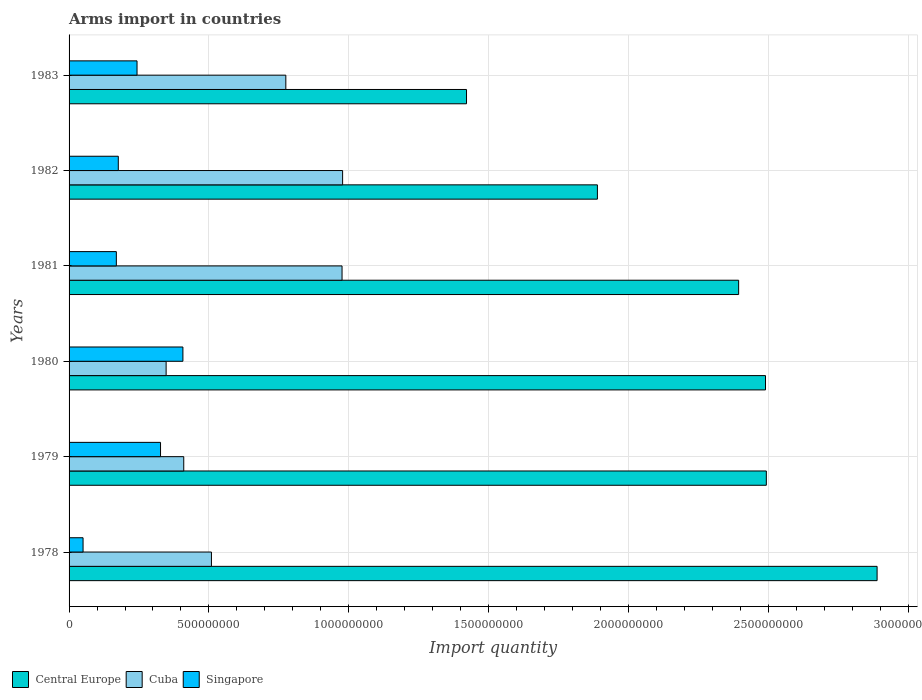How many different coloured bars are there?
Give a very brief answer. 3. Are the number of bars per tick equal to the number of legend labels?
Your answer should be very brief. Yes. Are the number of bars on each tick of the Y-axis equal?
Offer a very short reply. Yes. How many bars are there on the 6th tick from the bottom?
Give a very brief answer. 3. What is the total arms import in Singapore in 1980?
Your answer should be compact. 4.07e+08. Across all years, what is the maximum total arms import in Singapore?
Provide a succinct answer. 4.07e+08. Across all years, what is the minimum total arms import in Cuba?
Ensure brevity in your answer.  3.47e+08. In which year was the total arms import in Central Europe maximum?
Your response must be concise. 1978. In which year was the total arms import in Singapore minimum?
Keep it short and to the point. 1978. What is the total total arms import in Central Europe in the graph?
Your answer should be compact. 1.36e+1. What is the difference between the total arms import in Central Europe in 1981 and that in 1982?
Your response must be concise. 5.05e+08. What is the difference between the total arms import in Cuba in 1978 and the total arms import in Central Europe in 1983?
Provide a short and direct response. -9.12e+08. What is the average total arms import in Singapore per year?
Your answer should be very brief. 2.29e+08. In the year 1978, what is the difference between the total arms import in Singapore and total arms import in Cuba?
Provide a succinct answer. -4.59e+08. What is the ratio of the total arms import in Cuba in 1979 to that in 1982?
Keep it short and to the point. 0.42. Is the difference between the total arms import in Singapore in 1981 and 1983 greater than the difference between the total arms import in Cuba in 1981 and 1983?
Offer a terse response. No. What is the difference between the highest and the second highest total arms import in Central Europe?
Ensure brevity in your answer.  3.96e+08. What is the difference between the highest and the lowest total arms import in Central Europe?
Offer a very short reply. 1.47e+09. What does the 2nd bar from the top in 1979 represents?
Provide a succinct answer. Cuba. What does the 2nd bar from the bottom in 1978 represents?
Keep it short and to the point. Cuba. Is it the case that in every year, the sum of the total arms import in Singapore and total arms import in Cuba is greater than the total arms import in Central Europe?
Ensure brevity in your answer.  No. How many bars are there?
Your answer should be very brief. 18. Are the values on the major ticks of X-axis written in scientific E-notation?
Provide a succinct answer. No. Where does the legend appear in the graph?
Provide a succinct answer. Bottom left. How many legend labels are there?
Ensure brevity in your answer.  3. What is the title of the graph?
Keep it short and to the point. Arms import in countries. Does "Central African Republic" appear as one of the legend labels in the graph?
Provide a short and direct response. No. What is the label or title of the X-axis?
Your answer should be compact. Import quantity. What is the Import quantity of Central Europe in 1978?
Your answer should be compact. 2.89e+09. What is the Import quantity in Cuba in 1978?
Provide a succinct answer. 5.09e+08. What is the Import quantity of Central Europe in 1979?
Provide a short and direct response. 2.49e+09. What is the Import quantity in Cuba in 1979?
Your response must be concise. 4.10e+08. What is the Import quantity of Singapore in 1979?
Give a very brief answer. 3.27e+08. What is the Import quantity in Central Europe in 1980?
Ensure brevity in your answer.  2.49e+09. What is the Import quantity of Cuba in 1980?
Ensure brevity in your answer.  3.47e+08. What is the Import quantity of Singapore in 1980?
Your answer should be compact. 4.07e+08. What is the Import quantity in Central Europe in 1981?
Make the answer very short. 2.39e+09. What is the Import quantity of Cuba in 1981?
Your response must be concise. 9.76e+08. What is the Import quantity in Singapore in 1981?
Your response must be concise. 1.69e+08. What is the Import quantity in Central Europe in 1982?
Make the answer very short. 1.89e+09. What is the Import quantity of Cuba in 1982?
Your response must be concise. 9.78e+08. What is the Import quantity in Singapore in 1982?
Your answer should be compact. 1.76e+08. What is the Import quantity in Central Europe in 1983?
Offer a terse response. 1.42e+09. What is the Import quantity in Cuba in 1983?
Your response must be concise. 7.75e+08. What is the Import quantity of Singapore in 1983?
Your answer should be compact. 2.43e+08. Across all years, what is the maximum Import quantity of Central Europe?
Give a very brief answer. 2.89e+09. Across all years, what is the maximum Import quantity of Cuba?
Give a very brief answer. 9.78e+08. Across all years, what is the maximum Import quantity in Singapore?
Make the answer very short. 4.07e+08. Across all years, what is the minimum Import quantity of Central Europe?
Your answer should be very brief. 1.42e+09. Across all years, what is the minimum Import quantity of Cuba?
Give a very brief answer. 3.47e+08. Across all years, what is the minimum Import quantity in Singapore?
Offer a very short reply. 5.00e+07. What is the total Import quantity in Central Europe in the graph?
Offer a terse response. 1.36e+1. What is the total Import quantity of Cuba in the graph?
Provide a short and direct response. 4.00e+09. What is the total Import quantity of Singapore in the graph?
Offer a very short reply. 1.37e+09. What is the difference between the Import quantity of Central Europe in 1978 and that in 1979?
Provide a succinct answer. 3.96e+08. What is the difference between the Import quantity in Cuba in 1978 and that in 1979?
Ensure brevity in your answer.  9.90e+07. What is the difference between the Import quantity of Singapore in 1978 and that in 1979?
Your answer should be compact. -2.77e+08. What is the difference between the Import quantity in Central Europe in 1978 and that in 1980?
Offer a terse response. 3.99e+08. What is the difference between the Import quantity in Cuba in 1978 and that in 1980?
Offer a terse response. 1.62e+08. What is the difference between the Import quantity in Singapore in 1978 and that in 1980?
Offer a very short reply. -3.57e+08. What is the difference between the Import quantity in Central Europe in 1978 and that in 1981?
Your answer should be very brief. 4.95e+08. What is the difference between the Import quantity of Cuba in 1978 and that in 1981?
Provide a short and direct response. -4.67e+08. What is the difference between the Import quantity of Singapore in 1978 and that in 1981?
Your answer should be compact. -1.19e+08. What is the difference between the Import quantity in Cuba in 1978 and that in 1982?
Make the answer very short. -4.69e+08. What is the difference between the Import quantity of Singapore in 1978 and that in 1982?
Make the answer very short. -1.26e+08. What is the difference between the Import quantity of Central Europe in 1978 and that in 1983?
Your answer should be compact. 1.47e+09. What is the difference between the Import quantity of Cuba in 1978 and that in 1983?
Make the answer very short. -2.66e+08. What is the difference between the Import quantity of Singapore in 1978 and that in 1983?
Your answer should be compact. -1.93e+08. What is the difference between the Import quantity in Cuba in 1979 and that in 1980?
Provide a short and direct response. 6.30e+07. What is the difference between the Import quantity in Singapore in 1979 and that in 1980?
Provide a short and direct response. -8.00e+07. What is the difference between the Import quantity in Central Europe in 1979 and that in 1981?
Offer a terse response. 9.90e+07. What is the difference between the Import quantity of Cuba in 1979 and that in 1981?
Keep it short and to the point. -5.66e+08. What is the difference between the Import quantity of Singapore in 1979 and that in 1981?
Provide a short and direct response. 1.58e+08. What is the difference between the Import quantity of Central Europe in 1979 and that in 1982?
Your response must be concise. 6.04e+08. What is the difference between the Import quantity in Cuba in 1979 and that in 1982?
Your response must be concise. -5.68e+08. What is the difference between the Import quantity of Singapore in 1979 and that in 1982?
Offer a terse response. 1.51e+08. What is the difference between the Import quantity of Central Europe in 1979 and that in 1983?
Make the answer very short. 1.07e+09. What is the difference between the Import quantity in Cuba in 1979 and that in 1983?
Offer a terse response. -3.65e+08. What is the difference between the Import quantity of Singapore in 1979 and that in 1983?
Offer a terse response. 8.40e+07. What is the difference between the Import quantity in Central Europe in 1980 and that in 1981?
Provide a succinct answer. 9.60e+07. What is the difference between the Import quantity of Cuba in 1980 and that in 1981?
Your answer should be compact. -6.29e+08. What is the difference between the Import quantity in Singapore in 1980 and that in 1981?
Give a very brief answer. 2.38e+08. What is the difference between the Import quantity of Central Europe in 1980 and that in 1982?
Provide a succinct answer. 6.01e+08. What is the difference between the Import quantity in Cuba in 1980 and that in 1982?
Provide a succinct answer. -6.31e+08. What is the difference between the Import quantity in Singapore in 1980 and that in 1982?
Your response must be concise. 2.31e+08. What is the difference between the Import quantity in Central Europe in 1980 and that in 1983?
Give a very brief answer. 1.07e+09. What is the difference between the Import quantity of Cuba in 1980 and that in 1983?
Keep it short and to the point. -4.28e+08. What is the difference between the Import quantity in Singapore in 1980 and that in 1983?
Ensure brevity in your answer.  1.64e+08. What is the difference between the Import quantity of Central Europe in 1981 and that in 1982?
Offer a terse response. 5.05e+08. What is the difference between the Import quantity of Singapore in 1981 and that in 1982?
Provide a short and direct response. -7.00e+06. What is the difference between the Import quantity of Central Europe in 1981 and that in 1983?
Give a very brief answer. 9.73e+08. What is the difference between the Import quantity in Cuba in 1981 and that in 1983?
Keep it short and to the point. 2.01e+08. What is the difference between the Import quantity in Singapore in 1981 and that in 1983?
Give a very brief answer. -7.40e+07. What is the difference between the Import quantity in Central Europe in 1982 and that in 1983?
Your answer should be very brief. 4.68e+08. What is the difference between the Import quantity in Cuba in 1982 and that in 1983?
Provide a succinct answer. 2.03e+08. What is the difference between the Import quantity in Singapore in 1982 and that in 1983?
Your answer should be compact. -6.70e+07. What is the difference between the Import quantity of Central Europe in 1978 and the Import quantity of Cuba in 1979?
Your response must be concise. 2.48e+09. What is the difference between the Import quantity of Central Europe in 1978 and the Import quantity of Singapore in 1979?
Provide a short and direct response. 2.56e+09. What is the difference between the Import quantity in Cuba in 1978 and the Import quantity in Singapore in 1979?
Offer a terse response. 1.82e+08. What is the difference between the Import quantity in Central Europe in 1978 and the Import quantity in Cuba in 1980?
Keep it short and to the point. 2.54e+09. What is the difference between the Import quantity in Central Europe in 1978 and the Import quantity in Singapore in 1980?
Ensure brevity in your answer.  2.48e+09. What is the difference between the Import quantity in Cuba in 1978 and the Import quantity in Singapore in 1980?
Offer a terse response. 1.02e+08. What is the difference between the Import quantity of Central Europe in 1978 and the Import quantity of Cuba in 1981?
Give a very brief answer. 1.91e+09. What is the difference between the Import quantity of Central Europe in 1978 and the Import quantity of Singapore in 1981?
Provide a short and direct response. 2.72e+09. What is the difference between the Import quantity of Cuba in 1978 and the Import quantity of Singapore in 1981?
Offer a very short reply. 3.40e+08. What is the difference between the Import quantity of Central Europe in 1978 and the Import quantity of Cuba in 1982?
Provide a succinct answer. 1.91e+09. What is the difference between the Import quantity of Central Europe in 1978 and the Import quantity of Singapore in 1982?
Ensure brevity in your answer.  2.71e+09. What is the difference between the Import quantity of Cuba in 1978 and the Import quantity of Singapore in 1982?
Ensure brevity in your answer.  3.33e+08. What is the difference between the Import quantity in Central Europe in 1978 and the Import quantity in Cuba in 1983?
Your response must be concise. 2.11e+09. What is the difference between the Import quantity in Central Europe in 1978 and the Import quantity in Singapore in 1983?
Your response must be concise. 2.65e+09. What is the difference between the Import quantity of Cuba in 1978 and the Import quantity of Singapore in 1983?
Make the answer very short. 2.66e+08. What is the difference between the Import quantity of Central Europe in 1979 and the Import quantity of Cuba in 1980?
Give a very brief answer. 2.15e+09. What is the difference between the Import quantity in Central Europe in 1979 and the Import quantity in Singapore in 1980?
Offer a terse response. 2.09e+09. What is the difference between the Import quantity in Central Europe in 1979 and the Import quantity in Cuba in 1981?
Keep it short and to the point. 1.52e+09. What is the difference between the Import quantity in Central Europe in 1979 and the Import quantity in Singapore in 1981?
Offer a very short reply. 2.32e+09. What is the difference between the Import quantity in Cuba in 1979 and the Import quantity in Singapore in 1981?
Provide a succinct answer. 2.41e+08. What is the difference between the Import quantity in Central Europe in 1979 and the Import quantity in Cuba in 1982?
Keep it short and to the point. 1.52e+09. What is the difference between the Import quantity in Central Europe in 1979 and the Import quantity in Singapore in 1982?
Your answer should be very brief. 2.32e+09. What is the difference between the Import quantity of Cuba in 1979 and the Import quantity of Singapore in 1982?
Ensure brevity in your answer.  2.34e+08. What is the difference between the Import quantity of Central Europe in 1979 and the Import quantity of Cuba in 1983?
Your answer should be very brief. 1.72e+09. What is the difference between the Import quantity in Central Europe in 1979 and the Import quantity in Singapore in 1983?
Make the answer very short. 2.25e+09. What is the difference between the Import quantity in Cuba in 1979 and the Import quantity in Singapore in 1983?
Offer a very short reply. 1.67e+08. What is the difference between the Import quantity of Central Europe in 1980 and the Import quantity of Cuba in 1981?
Offer a terse response. 1.51e+09. What is the difference between the Import quantity of Central Europe in 1980 and the Import quantity of Singapore in 1981?
Your response must be concise. 2.32e+09. What is the difference between the Import quantity in Cuba in 1980 and the Import quantity in Singapore in 1981?
Provide a succinct answer. 1.78e+08. What is the difference between the Import quantity of Central Europe in 1980 and the Import quantity of Cuba in 1982?
Make the answer very short. 1.51e+09. What is the difference between the Import quantity of Central Europe in 1980 and the Import quantity of Singapore in 1982?
Provide a short and direct response. 2.31e+09. What is the difference between the Import quantity in Cuba in 1980 and the Import quantity in Singapore in 1982?
Provide a succinct answer. 1.71e+08. What is the difference between the Import quantity of Central Europe in 1980 and the Import quantity of Cuba in 1983?
Your answer should be very brief. 1.72e+09. What is the difference between the Import quantity of Central Europe in 1980 and the Import quantity of Singapore in 1983?
Ensure brevity in your answer.  2.25e+09. What is the difference between the Import quantity in Cuba in 1980 and the Import quantity in Singapore in 1983?
Keep it short and to the point. 1.04e+08. What is the difference between the Import quantity of Central Europe in 1981 and the Import quantity of Cuba in 1982?
Ensure brevity in your answer.  1.42e+09. What is the difference between the Import quantity in Central Europe in 1981 and the Import quantity in Singapore in 1982?
Ensure brevity in your answer.  2.22e+09. What is the difference between the Import quantity of Cuba in 1981 and the Import quantity of Singapore in 1982?
Offer a terse response. 8.00e+08. What is the difference between the Import quantity in Central Europe in 1981 and the Import quantity in Cuba in 1983?
Give a very brief answer. 1.62e+09. What is the difference between the Import quantity in Central Europe in 1981 and the Import quantity in Singapore in 1983?
Give a very brief answer. 2.15e+09. What is the difference between the Import quantity of Cuba in 1981 and the Import quantity of Singapore in 1983?
Your answer should be compact. 7.33e+08. What is the difference between the Import quantity of Central Europe in 1982 and the Import quantity of Cuba in 1983?
Offer a terse response. 1.11e+09. What is the difference between the Import quantity in Central Europe in 1982 and the Import quantity in Singapore in 1983?
Offer a terse response. 1.65e+09. What is the difference between the Import quantity in Cuba in 1982 and the Import quantity in Singapore in 1983?
Make the answer very short. 7.35e+08. What is the average Import quantity in Central Europe per year?
Provide a short and direct response. 2.26e+09. What is the average Import quantity of Cuba per year?
Ensure brevity in your answer.  6.66e+08. What is the average Import quantity of Singapore per year?
Ensure brevity in your answer.  2.29e+08. In the year 1978, what is the difference between the Import quantity in Central Europe and Import quantity in Cuba?
Your answer should be very brief. 2.38e+09. In the year 1978, what is the difference between the Import quantity in Central Europe and Import quantity in Singapore?
Provide a succinct answer. 2.84e+09. In the year 1978, what is the difference between the Import quantity in Cuba and Import quantity in Singapore?
Your answer should be compact. 4.59e+08. In the year 1979, what is the difference between the Import quantity of Central Europe and Import quantity of Cuba?
Your answer should be very brief. 2.08e+09. In the year 1979, what is the difference between the Import quantity in Central Europe and Import quantity in Singapore?
Offer a terse response. 2.17e+09. In the year 1979, what is the difference between the Import quantity of Cuba and Import quantity of Singapore?
Keep it short and to the point. 8.30e+07. In the year 1980, what is the difference between the Import quantity in Central Europe and Import quantity in Cuba?
Ensure brevity in your answer.  2.14e+09. In the year 1980, what is the difference between the Import quantity in Central Europe and Import quantity in Singapore?
Offer a very short reply. 2.08e+09. In the year 1980, what is the difference between the Import quantity in Cuba and Import quantity in Singapore?
Ensure brevity in your answer.  -6.00e+07. In the year 1981, what is the difference between the Import quantity of Central Europe and Import quantity of Cuba?
Your answer should be compact. 1.42e+09. In the year 1981, what is the difference between the Import quantity of Central Europe and Import quantity of Singapore?
Provide a short and direct response. 2.22e+09. In the year 1981, what is the difference between the Import quantity of Cuba and Import quantity of Singapore?
Give a very brief answer. 8.07e+08. In the year 1982, what is the difference between the Import quantity in Central Europe and Import quantity in Cuba?
Provide a succinct answer. 9.11e+08. In the year 1982, what is the difference between the Import quantity of Central Europe and Import quantity of Singapore?
Your answer should be very brief. 1.71e+09. In the year 1982, what is the difference between the Import quantity in Cuba and Import quantity in Singapore?
Offer a very short reply. 8.02e+08. In the year 1983, what is the difference between the Import quantity in Central Europe and Import quantity in Cuba?
Offer a very short reply. 6.46e+08. In the year 1983, what is the difference between the Import quantity of Central Europe and Import quantity of Singapore?
Your response must be concise. 1.18e+09. In the year 1983, what is the difference between the Import quantity of Cuba and Import quantity of Singapore?
Your answer should be compact. 5.32e+08. What is the ratio of the Import quantity in Central Europe in 1978 to that in 1979?
Keep it short and to the point. 1.16. What is the ratio of the Import quantity of Cuba in 1978 to that in 1979?
Your answer should be compact. 1.24. What is the ratio of the Import quantity in Singapore in 1978 to that in 1979?
Your answer should be very brief. 0.15. What is the ratio of the Import quantity of Central Europe in 1978 to that in 1980?
Keep it short and to the point. 1.16. What is the ratio of the Import quantity in Cuba in 1978 to that in 1980?
Your answer should be compact. 1.47. What is the ratio of the Import quantity in Singapore in 1978 to that in 1980?
Provide a short and direct response. 0.12. What is the ratio of the Import quantity in Central Europe in 1978 to that in 1981?
Make the answer very short. 1.21. What is the ratio of the Import quantity of Cuba in 1978 to that in 1981?
Provide a short and direct response. 0.52. What is the ratio of the Import quantity of Singapore in 1978 to that in 1981?
Make the answer very short. 0.3. What is the ratio of the Import quantity of Central Europe in 1978 to that in 1982?
Your response must be concise. 1.53. What is the ratio of the Import quantity of Cuba in 1978 to that in 1982?
Keep it short and to the point. 0.52. What is the ratio of the Import quantity of Singapore in 1978 to that in 1982?
Your answer should be very brief. 0.28. What is the ratio of the Import quantity of Central Europe in 1978 to that in 1983?
Ensure brevity in your answer.  2.03. What is the ratio of the Import quantity in Cuba in 1978 to that in 1983?
Offer a terse response. 0.66. What is the ratio of the Import quantity in Singapore in 1978 to that in 1983?
Offer a terse response. 0.21. What is the ratio of the Import quantity of Central Europe in 1979 to that in 1980?
Offer a very short reply. 1. What is the ratio of the Import quantity of Cuba in 1979 to that in 1980?
Keep it short and to the point. 1.18. What is the ratio of the Import quantity of Singapore in 1979 to that in 1980?
Give a very brief answer. 0.8. What is the ratio of the Import quantity of Central Europe in 1979 to that in 1981?
Your answer should be very brief. 1.04. What is the ratio of the Import quantity of Cuba in 1979 to that in 1981?
Your answer should be very brief. 0.42. What is the ratio of the Import quantity of Singapore in 1979 to that in 1981?
Your response must be concise. 1.93. What is the ratio of the Import quantity in Central Europe in 1979 to that in 1982?
Offer a terse response. 1.32. What is the ratio of the Import quantity in Cuba in 1979 to that in 1982?
Your answer should be very brief. 0.42. What is the ratio of the Import quantity in Singapore in 1979 to that in 1982?
Offer a very short reply. 1.86. What is the ratio of the Import quantity of Central Europe in 1979 to that in 1983?
Offer a very short reply. 1.75. What is the ratio of the Import quantity of Cuba in 1979 to that in 1983?
Your response must be concise. 0.53. What is the ratio of the Import quantity in Singapore in 1979 to that in 1983?
Ensure brevity in your answer.  1.35. What is the ratio of the Import quantity of Central Europe in 1980 to that in 1981?
Provide a succinct answer. 1.04. What is the ratio of the Import quantity of Cuba in 1980 to that in 1981?
Make the answer very short. 0.36. What is the ratio of the Import quantity of Singapore in 1980 to that in 1981?
Offer a terse response. 2.41. What is the ratio of the Import quantity of Central Europe in 1980 to that in 1982?
Provide a short and direct response. 1.32. What is the ratio of the Import quantity in Cuba in 1980 to that in 1982?
Keep it short and to the point. 0.35. What is the ratio of the Import quantity in Singapore in 1980 to that in 1982?
Offer a very short reply. 2.31. What is the ratio of the Import quantity of Central Europe in 1980 to that in 1983?
Your answer should be very brief. 1.75. What is the ratio of the Import quantity in Cuba in 1980 to that in 1983?
Offer a terse response. 0.45. What is the ratio of the Import quantity of Singapore in 1980 to that in 1983?
Ensure brevity in your answer.  1.67. What is the ratio of the Import quantity of Central Europe in 1981 to that in 1982?
Provide a succinct answer. 1.27. What is the ratio of the Import quantity of Cuba in 1981 to that in 1982?
Offer a terse response. 1. What is the ratio of the Import quantity in Singapore in 1981 to that in 1982?
Offer a very short reply. 0.96. What is the ratio of the Import quantity in Central Europe in 1981 to that in 1983?
Offer a terse response. 1.68. What is the ratio of the Import quantity of Cuba in 1981 to that in 1983?
Offer a terse response. 1.26. What is the ratio of the Import quantity of Singapore in 1981 to that in 1983?
Ensure brevity in your answer.  0.7. What is the ratio of the Import quantity in Central Europe in 1982 to that in 1983?
Provide a succinct answer. 1.33. What is the ratio of the Import quantity in Cuba in 1982 to that in 1983?
Ensure brevity in your answer.  1.26. What is the ratio of the Import quantity in Singapore in 1982 to that in 1983?
Make the answer very short. 0.72. What is the difference between the highest and the second highest Import quantity in Central Europe?
Offer a very short reply. 3.96e+08. What is the difference between the highest and the second highest Import quantity of Cuba?
Give a very brief answer. 2.00e+06. What is the difference between the highest and the second highest Import quantity in Singapore?
Keep it short and to the point. 8.00e+07. What is the difference between the highest and the lowest Import quantity of Central Europe?
Your answer should be very brief. 1.47e+09. What is the difference between the highest and the lowest Import quantity in Cuba?
Your answer should be very brief. 6.31e+08. What is the difference between the highest and the lowest Import quantity in Singapore?
Offer a very short reply. 3.57e+08. 